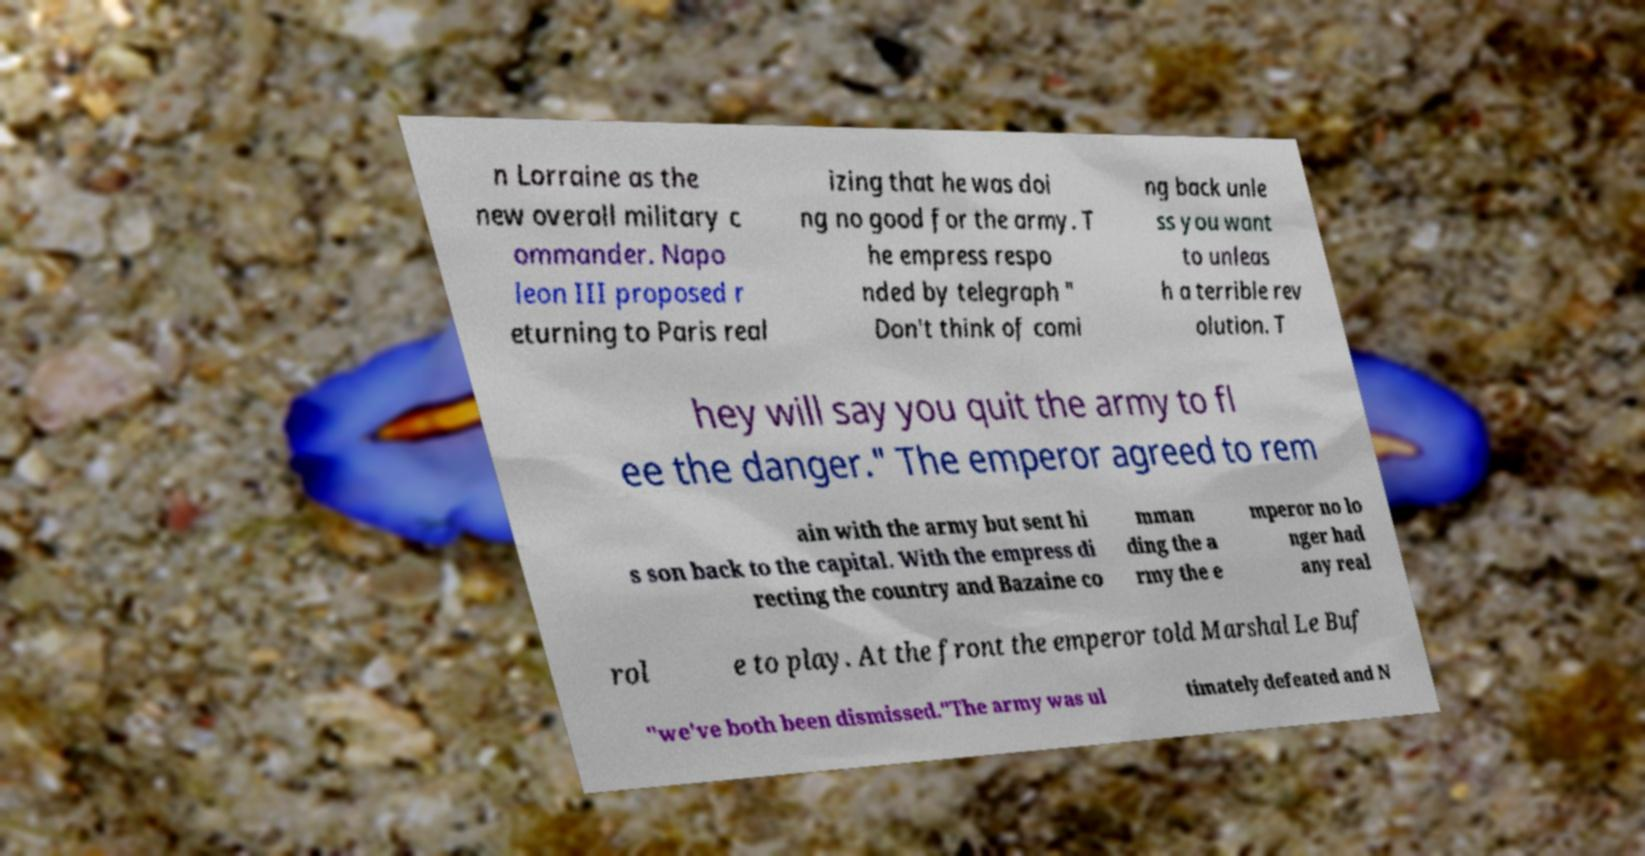I need the written content from this picture converted into text. Can you do that? n Lorraine as the new overall military c ommander. Napo leon III proposed r eturning to Paris real izing that he was doi ng no good for the army. T he empress respo nded by telegraph " Don't think of comi ng back unle ss you want to unleas h a terrible rev olution. T hey will say you quit the army to fl ee the danger." The emperor agreed to rem ain with the army but sent hi s son back to the capital. With the empress di recting the country and Bazaine co mman ding the a rmy the e mperor no lo nger had any real rol e to play. At the front the emperor told Marshal Le Buf "we've both been dismissed."The army was ul timately defeated and N 